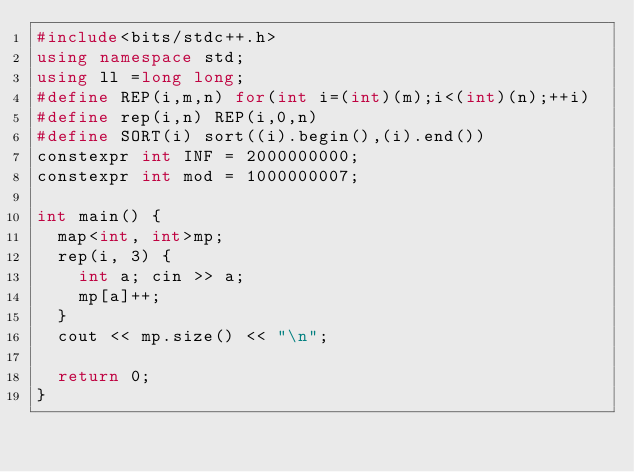<code> <loc_0><loc_0><loc_500><loc_500><_C++_>#include<bits/stdc++.h>
using namespace std;
using ll =long long;
#define REP(i,m,n) for(int i=(int)(m);i<(int)(n);++i)
#define rep(i,n) REP(i,0,n)
#define SORT(i) sort((i).begin(),(i).end())
constexpr int INF = 2000000000;
constexpr int mod = 1000000007;

int main() {
	map<int, int>mp;
	rep(i, 3) {
		int a; cin >> a;
		mp[a]++;
	}
	cout << mp.size() << "\n";

	return 0;
}</code> 